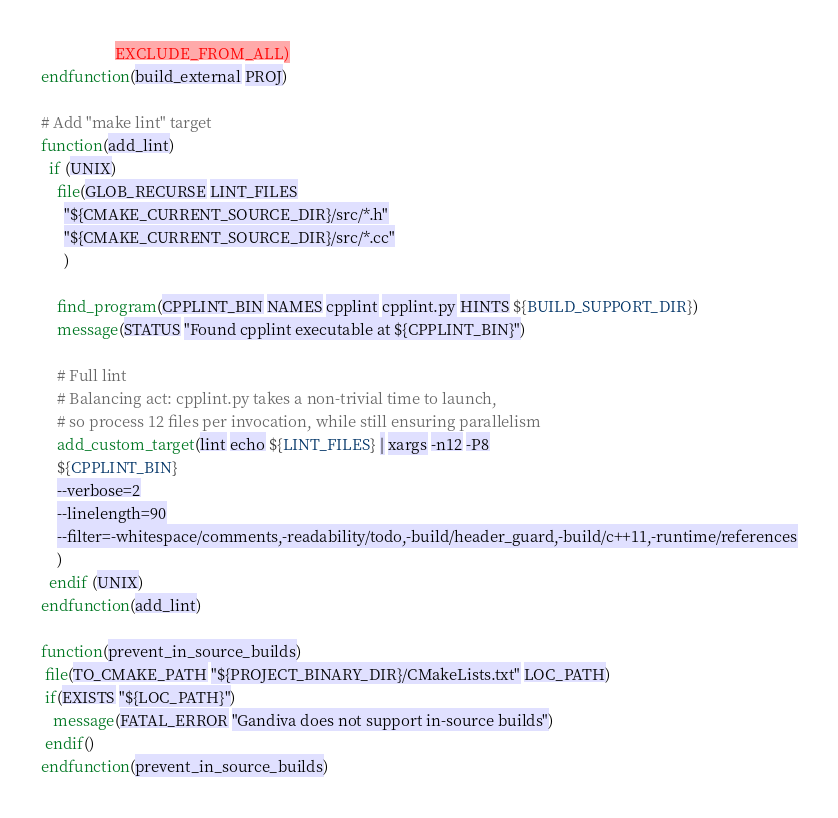<code> <loc_0><loc_0><loc_500><loc_500><_CMake_>                   EXCLUDE_FROM_ALL)
endfunction(build_external PROJ)

# Add "make lint" target
function(add_lint)
  if (UNIX)
    file(GLOB_RECURSE LINT_FILES
      "${CMAKE_CURRENT_SOURCE_DIR}/src/*.h"
      "${CMAKE_CURRENT_SOURCE_DIR}/src/*.cc"
      )

    find_program(CPPLINT_BIN NAMES cpplint cpplint.py HINTS ${BUILD_SUPPORT_DIR})
    message(STATUS "Found cpplint executable at ${CPPLINT_BIN}")

    # Full lint
    # Balancing act: cpplint.py takes a non-trivial time to launch,
    # so process 12 files per invocation, while still ensuring parallelism
    add_custom_target(lint echo ${LINT_FILES} | xargs -n12 -P8
    ${CPPLINT_BIN}
    --verbose=2
    --linelength=90
    --filter=-whitespace/comments,-readability/todo,-build/header_guard,-build/c++11,-runtime/references
    )
  endif (UNIX)
endfunction(add_lint)

function(prevent_in_source_builds)
 file(TO_CMAKE_PATH "${PROJECT_BINARY_DIR}/CMakeLists.txt" LOC_PATH)
 if(EXISTS "${LOC_PATH}")
   message(FATAL_ERROR "Gandiva does not support in-source builds")
 endif()
endfunction(prevent_in_source_builds)
</code> 